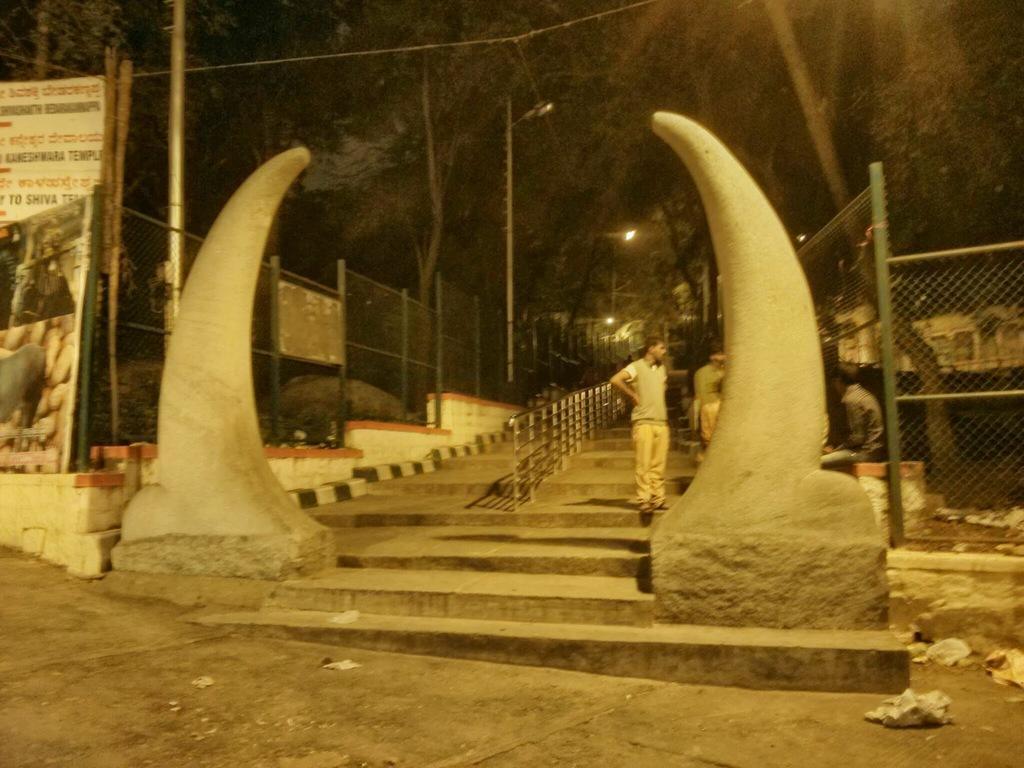Can you describe this image briefly? In this image we can see two people standing on the staircase. We can also see the railing, the sculptures beside the staircase and the metal fence. On the left side we can see a banner with some text and pictures on it. On the right side we can see a building. We can also see some poles, wires and a group of trees. 